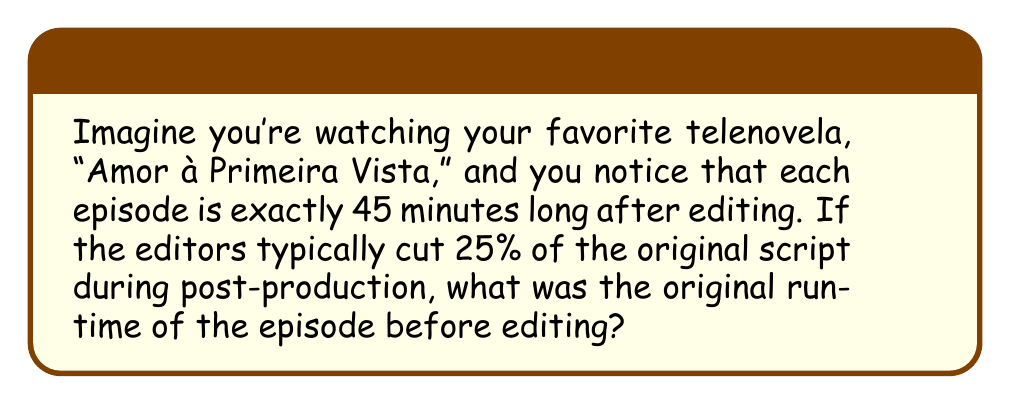Show me your answer to this math problem. Let's approach this step-by-step:

1) Let $x$ be the original runtime of the episode in minutes.

2) We know that after editing, 75% of the original runtime remains (since 25% was cut).

3) We can express this as an equation:
   $0.75x = 45$

4) To solve for $x$, we divide both sides by 0.75:
   $x = \frac{45}{0.75}$

5) Simplify:
   $x = 45 \cdot \frac{4}{3} = 60$

Therefore, the original runtime of the episode before editing was 60 minutes.
Answer: 60 minutes 